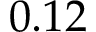Convert formula to latex. <formula><loc_0><loc_0><loc_500><loc_500>0 . 1 2</formula> 